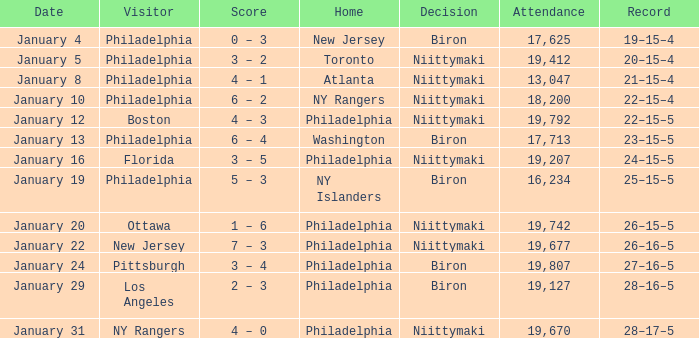Would you be able to parse every entry in this table? {'header': ['Date', 'Visitor', 'Score', 'Home', 'Decision', 'Attendance', 'Record'], 'rows': [['January 4', 'Philadelphia', '0 – 3', 'New Jersey', 'Biron', '17,625', '19–15–4'], ['January 5', 'Philadelphia', '3 – 2', 'Toronto', 'Niittymaki', '19,412', '20–15–4'], ['January 8', 'Philadelphia', '4 – 1', 'Atlanta', 'Niittymaki', '13,047', '21–15–4'], ['January 10', 'Philadelphia', '6 – 2', 'NY Rangers', 'Niittymaki', '18,200', '22–15–4'], ['January 12', 'Boston', '4 – 3', 'Philadelphia', 'Niittymaki', '19,792', '22–15–5'], ['January 13', 'Philadelphia', '6 – 4', 'Washington', 'Biron', '17,713', '23–15–5'], ['January 16', 'Florida', '3 – 5', 'Philadelphia', 'Niittymaki', '19,207', '24–15–5'], ['January 19', 'Philadelphia', '5 – 3', 'NY Islanders', 'Biron', '16,234', '25–15–5'], ['January 20', 'Ottawa', '1 – 6', 'Philadelphia', 'Niittymaki', '19,742', '26–15–5'], ['January 22', 'New Jersey', '7 – 3', 'Philadelphia', 'Niittymaki', '19,677', '26–16–5'], ['January 24', 'Pittsburgh', '3 – 4', 'Philadelphia', 'Biron', '19,807', '27–16–5'], ['January 29', 'Los Angeles', '2 – 3', 'Philadelphia', 'Biron', '19,127', '28–16–5'], ['January 31', 'NY Rangers', '4 – 0', 'Philadelphia', 'Niittymaki', '19,670', '28–17–5']]} When was the day the verdict pertained to niittymaki, the crowd went beyond 19,207, and the record displayed 28-17-5? January 31. 